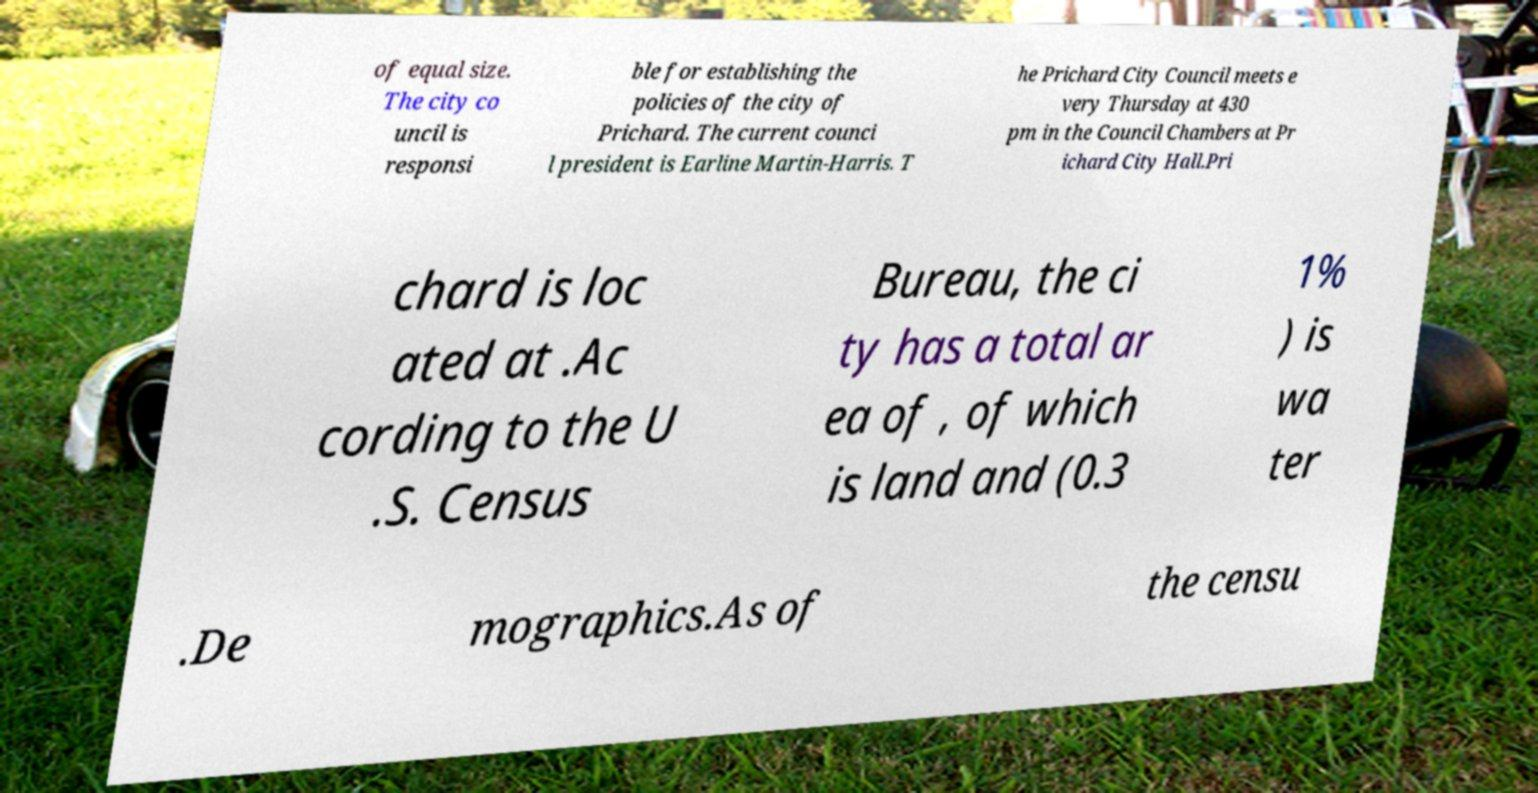What messages or text are displayed in this image? I need them in a readable, typed format. of equal size. The city co uncil is responsi ble for establishing the policies of the city of Prichard. The current counci l president is Earline Martin-Harris. T he Prichard City Council meets e very Thursday at 430 pm in the Council Chambers at Pr ichard City Hall.Pri chard is loc ated at .Ac cording to the U .S. Census Bureau, the ci ty has a total ar ea of , of which is land and (0.3 1% ) is wa ter .De mographics.As of the censu 